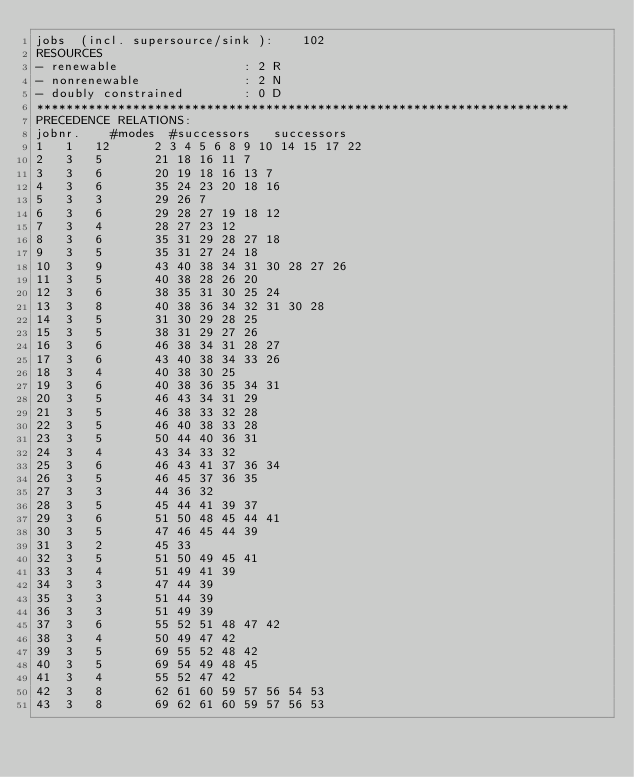<code> <loc_0><loc_0><loc_500><loc_500><_ObjectiveC_>jobs  (incl. supersource/sink ):	102
RESOURCES
- renewable                 : 2 R
- nonrenewable              : 2 N
- doubly constrained        : 0 D
************************************************************************
PRECEDENCE RELATIONS:
jobnr.    #modes  #successors   successors
1	1	12		2 3 4 5 6 8 9 10 14 15 17 22 
2	3	5		21 18 16 11 7 
3	3	6		20 19 18 16 13 7 
4	3	6		35 24 23 20 18 16 
5	3	3		29 26 7 
6	3	6		29 28 27 19 18 12 
7	3	4		28 27 23 12 
8	3	6		35 31 29 28 27 18 
9	3	5		35 31 27 24 18 
10	3	9		43 40 38 34 31 30 28 27 26 
11	3	5		40 38 28 26 20 
12	3	6		38 35 31 30 25 24 
13	3	8		40 38 36 34 32 31 30 28 
14	3	5		31 30 29 28 25 
15	3	5		38 31 29 27 26 
16	3	6		46 38 34 31 28 27 
17	3	6		43 40 38 34 33 26 
18	3	4		40 38 30 25 
19	3	6		40 38 36 35 34 31 
20	3	5		46 43 34 31 29 
21	3	5		46 38 33 32 28 
22	3	5		46 40 38 33 28 
23	3	5		50 44 40 36 31 
24	3	4		43 34 33 32 
25	3	6		46 43 41 37 36 34 
26	3	5		46 45 37 36 35 
27	3	3		44 36 32 
28	3	5		45 44 41 39 37 
29	3	6		51 50 48 45 44 41 
30	3	5		47 46 45 44 39 
31	3	2		45 33 
32	3	5		51 50 49 45 41 
33	3	4		51 49 41 39 
34	3	3		47 44 39 
35	3	3		51 44 39 
36	3	3		51 49 39 
37	3	6		55 52 51 48 47 42 
38	3	4		50 49 47 42 
39	3	5		69 55 52 48 42 
40	3	5		69 54 49 48 45 
41	3	4		55 52 47 42 
42	3	8		62 61 60 59 57 56 54 53 
43	3	8		69 62 61 60 59 57 56 53 </code> 